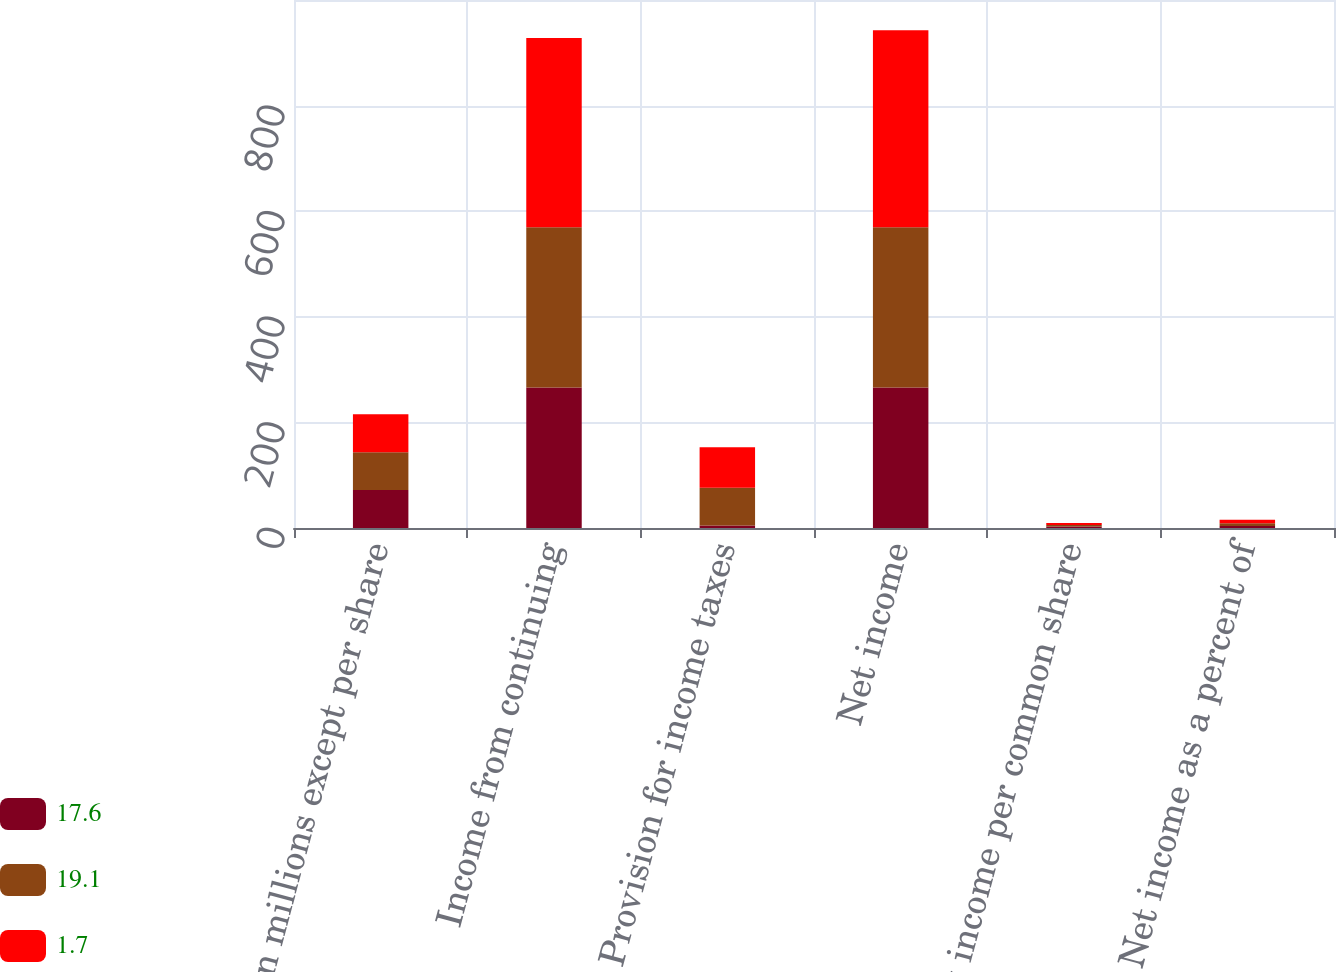Convert chart to OTSL. <chart><loc_0><loc_0><loc_500><loc_500><stacked_bar_chart><ecel><fcel>(In millions except per share<fcel>Income from continuing<fcel>Provision for income taxes<fcel>Net income<fcel>Net income per common share<fcel>Net income as a percent of<nl><fcel>17.6<fcel>71.8<fcel>266.1<fcel>4.5<fcel>266.1<fcel>2.7<fcel>4<nl><fcel>19.1<fcel>71.8<fcel>303.5<fcel>71.8<fcel>303.5<fcel>3.07<fcel>4.8<nl><fcel>1.7<fcel>71.8<fcel>358.5<fcel>76.7<fcel>373.2<fcel>3.72<fcel>6.7<nl></chart> 